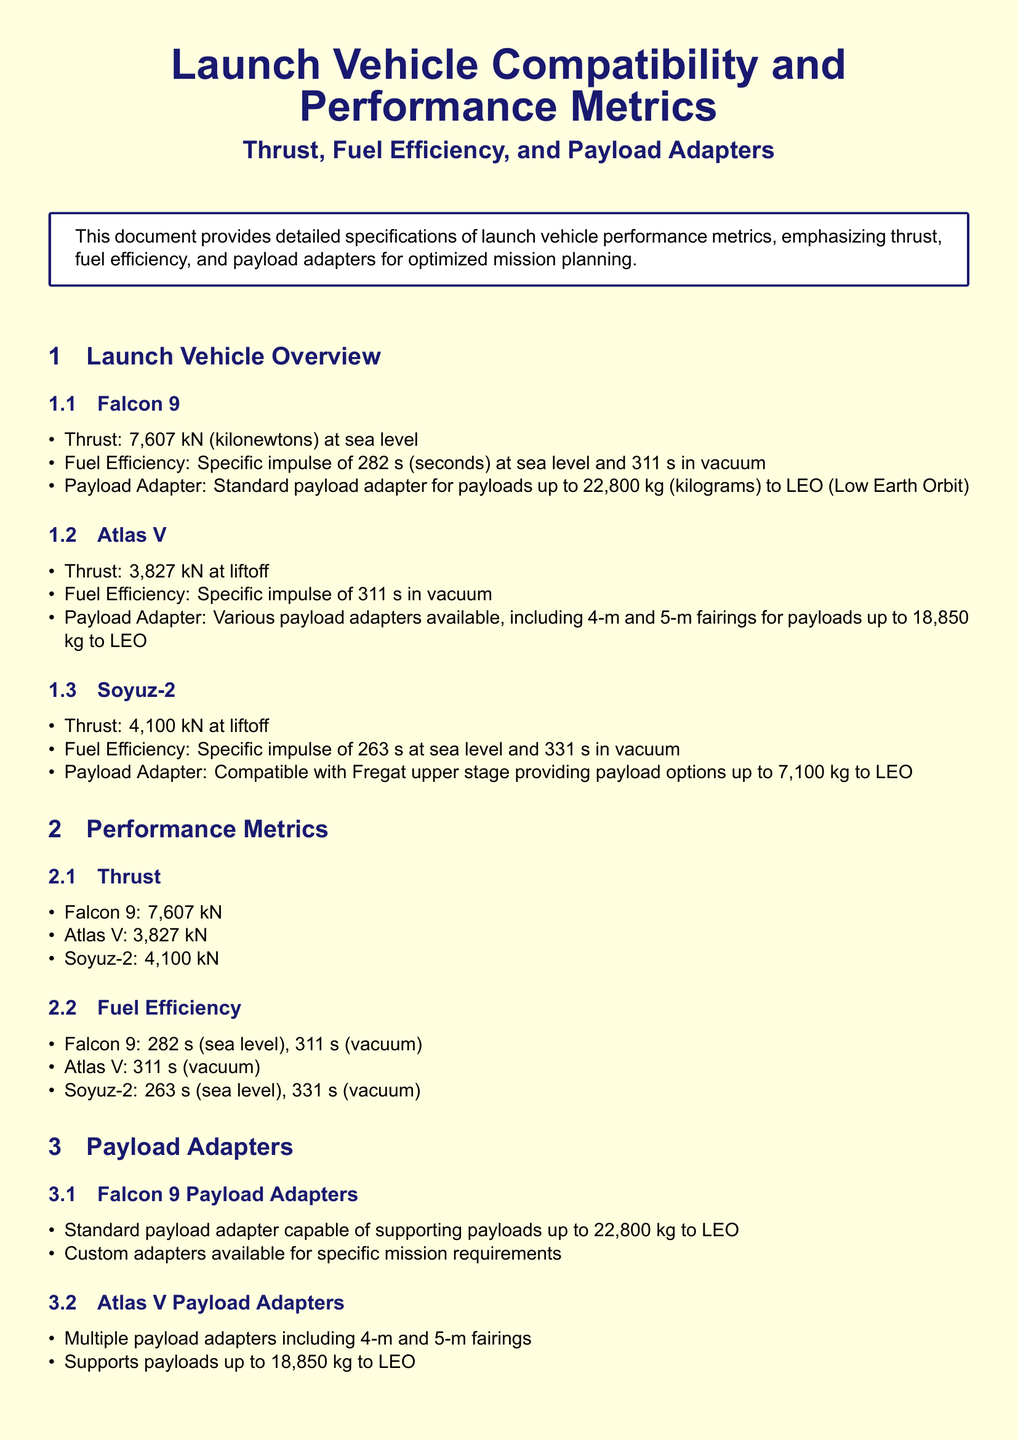What is the thrust of Falcon 9? The thrust of Falcon 9 is specified in the document as 7,607 kN at sea level.
Answer: 7,607 kN What is the fuel efficiency of Atlas V in vacuum? The document states that Atlas V has a specific impulse of 311 seconds in vacuum.
Answer: 311 s What is the maximum payload capacity of Soyuz-2? The document indicates that Soyuz-2 can support payloads up to 7,100 kg to Low Earth Orbit.
Answer: 7,100 kg Which launch vehicle has the highest thrust? The thrust values for all vehicles are listed, and Falcon 9 clearly has the highest thrust at 7,607 kN.
Answer: Falcon 9 Which payload adapter supports up to 22,800 kg? The document specifies that Falcon 9 has a standard payload adapter capable of supporting payloads up to 22,800 kg.
Answer: Falcon 9 How many different payload adapters does Atlas V offer? The document mentions multiple payload adapters for Atlas V, specifically including 4-m and 5-m fairings.
Answer: Multiple What is the fuel efficiency (specific impulse) of Soyuz-2 at sea level? The document indicates that Soyuz-2 has a specific impulse of 263 seconds at sea level.
Answer: 263 s What is the purpose of this document? The document outlines that it provides detailed specifications of launch vehicle performance metrics for optimized mission planning.
Answer: Optimized mission planning What does the conclusion emphasize? The conclusion is focused on helping mission planners select the appropriate launch vehicle based on thrust, fuel efficiency, and payload adapters.
Answer: Selection of launch vehicle 